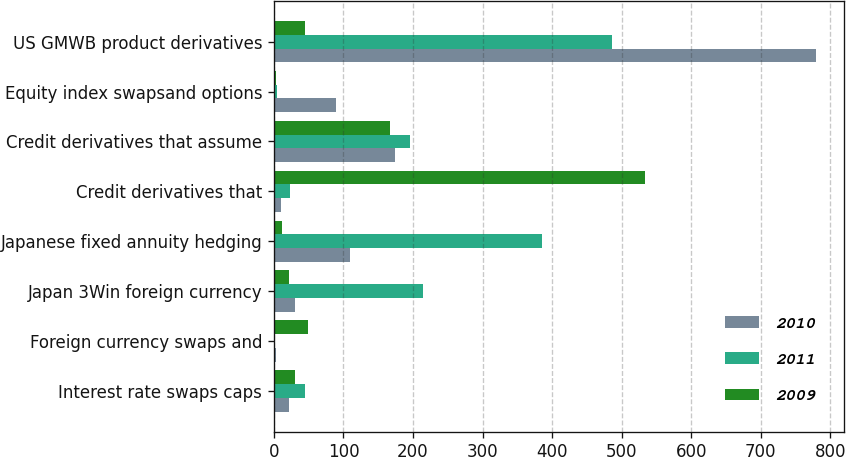Convert chart. <chart><loc_0><loc_0><loc_500><loc_500><stacked_bar_chart><ecel><fcel>Interest rate swaps caps<fcel>Foreign currency swaps and<fcel>Japan 3Win foreign currency<fcel>Japanese fixed annuity hedging<fcel>Credit derivatives that<fcel>Credit derivatives that assume<fcel>Equity index swapsand options<fcel>US GMWB product derivatives<nl><fcel>2010<fcel>22<fcel>3<fcel>31<fcel>109<fcel>10<fcel>174<fcel>89<fcel>780<nl><fcel>2011<fcel>45<fcel>1<fcel>215<fcel>385<fcel>23<fcel>196<fcel>5<fcel>486<nl><fcel>2009<fcel>31<fcel>49<fcel>22<fcel>12<fcel>533<fcel>167<fcel>3<fcel>45<nl></chart> 